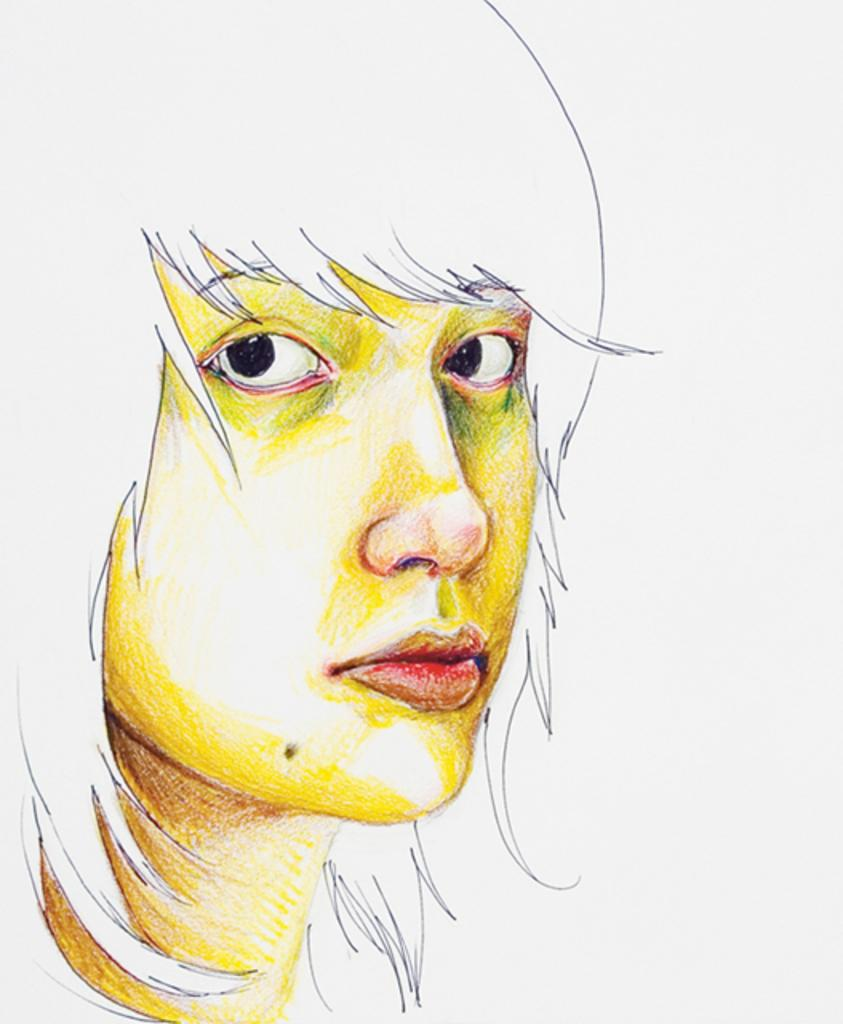What is the main subject of the image? The main subject of the image is a drawing of a girl. What color is the background of the image? The background of the image is white. What is the price of the drawing in the image? There is no information about the price of the drawing in the image. What type of verse can be seen in the image? There is no verse present in the image; it is a drawing of a girl with a white background. 